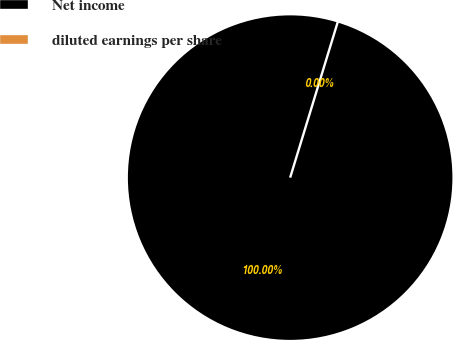Convert chart to OTSL. <chart><loc_0><loc_0><loc_500><loc_500><pie_chart><fcel>Net income<fcel>diluted earnings per share<nl><fcel>100.0%<fcel>0.0%<nl></chart> 